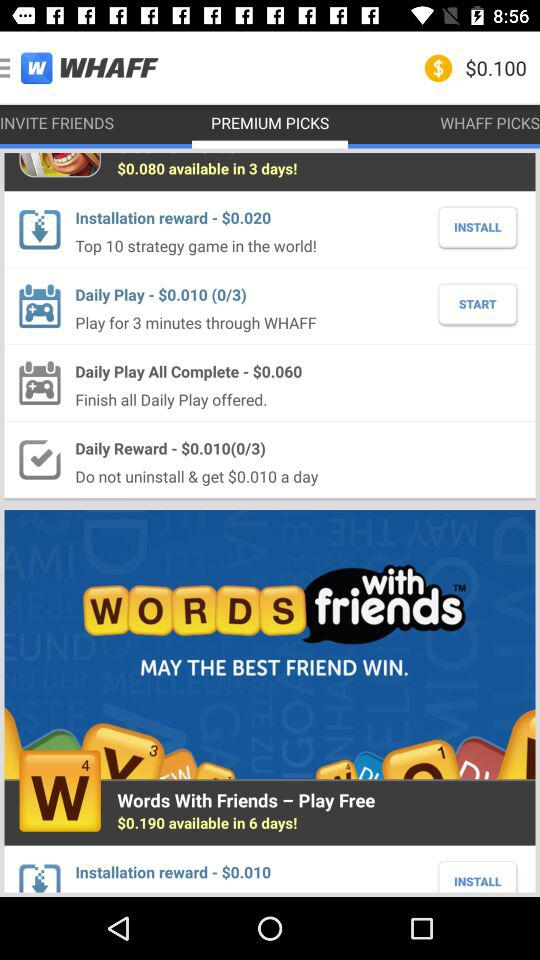What is the balance? The balance is $0.100. 